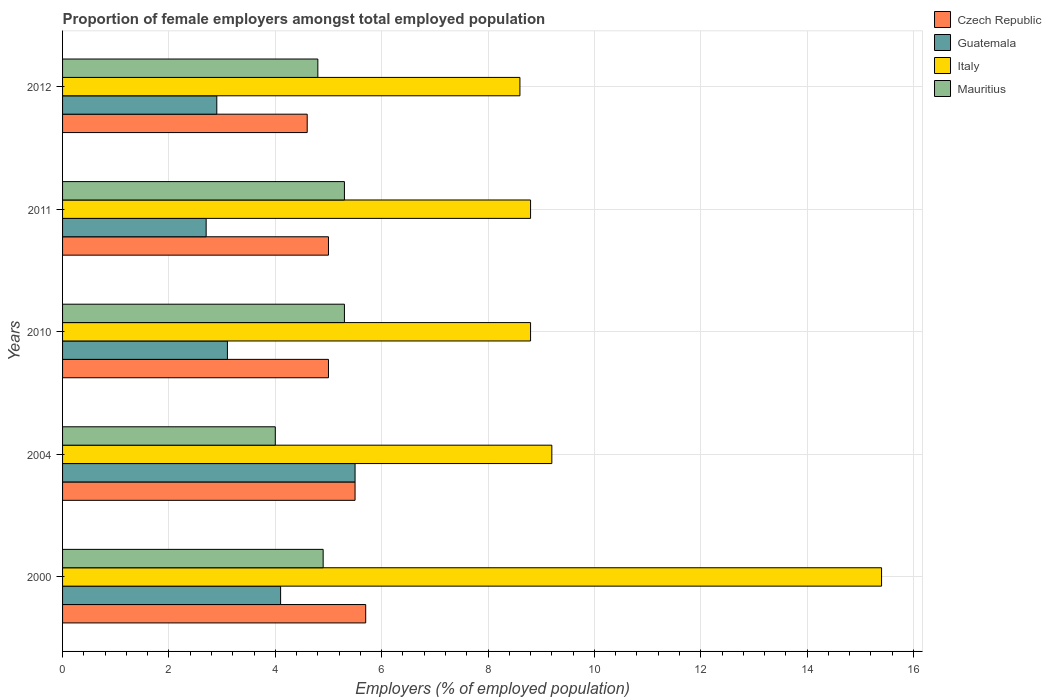How many different coloured bars are there?
Offer a terse response. 4. How many groups of bars are there?
Ensure brevity in your answer.  5. Are the number of bars per tick equal to the number of legend labels?
Your response must be concise. Yes. Are the number of bars on each tick of the Y-axis equal?
Provide a succinct answer. Yes. How many bars are there on the 1st tick from the top?
Your answer should be very brief. 4. What is the proportion of female employers in Mauritius in 2012?
Provide a short and direct response. 4.8. Across all years, what is the maximum proportion of female employers in Italy?
Your answer should be compact. 15.4. Across all years, what is the minimum proportion of female employers in Italy?
Your response must be concise. 8.6. In which year was the proportion of female employers in Italy maximum?
Give a very brief answer. 2000. What is the total proportion of female employers in Italy in the graph?
Provide a short and direct response. 50.8. What is the difference between the proportion of female employers in Czech Republic in 2010 and that in 2012?
Offer a terse response. 0.4. What is the difference between the proportion of female employers in Czech Republic in 2011 and the proportion of female employers in Mauritius in 2012?
Your answer should be compact. 0.2. What is the average proportion of female employers in Italy per year?
Your answer should be very brief. 10.16. In the year 2011, what is the difference between the proportion of female employers in Guatemala and proportion of female employers in Italy?
Offer a terse response. -6.1. In how many years, is the proportion of female employers in Guatemala greater than 7.6 %?
Provide a succinct answer. 0. What is the ratio of the proportion of female employers in Guatemala in 2004 to that in 2010?
Keep it short and to the point. 1.77. Is the proportion of female employers in Czech Republic in 2010 less than that in 2012?
Your answer should be very brief. No. Is the difference between the proportion of female employers in Guatemala in 2000 and 2010 greater than the difference between the proportion of female employers in Italy in 2000 and 2010?
Make the answer very short. No. What is the difference between the highest and the second highest proportion of female employers in Italy?
Keep it short and to the point. 6.2. What is the difference between the highest and the lowest proportion of female employers in Italy?
Provide a short and direct response. 6.8. In how many years, is the proportion of female employers in Mauritius greater than the average proportion of female employers in Mauritius taken over all years?
Keep it short and to the point. 3. What does the 4th bar from the top in 2012 represents?
Your answer should be compact. Czech Republic. What does the 4th bar from the bottom in 2012 represents?
Keep it short and to the point. Mauritius. How many bars are there?
Give a very brief answer. 20. Are the values on the major ticks of X-axis written in scientific E-notation?
Offer a very short reply. No. Where does the legend appear in the graph?
Your answer should be very brief. Top right. How many legend labels are there?
Offer a terse response. 4. How are the legend labels stacked?
Make the answer very short. Vertical. What is the title of the graph?
Your response must be concise. Proportion of female employers amongst total employed population. What is the label or title of the X-axis?
Your answer should be compact. Employers (% of employed population). What is the label or title of the Y-axis?
Your answer should be compact. Years. What is the Employers (% of employed population) in Czech Republic in 2000?
Make the answer very short. 5.7. What is the Employers (% of employed population) in Guatemala in 2000?
Offer a very short reply. 4.1. What is the Employers (% of employed population) in Italy in 2000?
Give a very brief answer. 15.4. What is the Employers (% of employed population) in Mauritius in 2000?
Ensure brevity in your answer.  4.9. What is the Employers (% of employed population) in Guatemala in 2004?
Your answer should be compact. 5.5. What is the Employers (% of employed population) in Italy in 2004?
Provide a short and direct response. 9.2. What is the Employers (% of employed population) of Czech Republic in 2010?
Make the answer very short. 5. What is the Employers (% of employed population) of Guatemala in 2010?
Your response must be concise. 3.1. What is the Employers (% of employed population) of Italy in 2010?
Provide a short and direct response. 8.8. What is the Employers (% of employed population) of Mauritius in 2010?
Offer a very short reply. 5.3. What is the Employers (% of employed population) in Czech Republic in 2011?
Make the answer very short. 5. What is the Employers (% of employed population) of Guatemala in 2011?
Your response must be concise. 2.7. What is the Employers (% of employed population) of Italy in 2011?
Offer a terse response. 8.8. What is the Employers (% of employed population) in Mauritius in 2011?
Your response must be concise. 5.3. What is the Employers (% of employed population) of Czech Republic in 2012?
Provide a succinct answer. 4.6. What is the Employers (% of employed population) in Guatemala in 2012?
Provide a short and direct response. 2.9. What is the Employers (% of employed population) in Italy in 2012?
Offer a terse response. 8.6. What is the Employers (% of employed population) of Mauritius in 2012?
Your response must be concise. 4.8. Across all years, what is the maximum Employers (% of employed population) of Czech Republic?
Your answer should be very brief. 5.7. Across all years, what is the maximum Employers (% of employed population) in Italy?
Your answer should be very brief. 15.4. Across all years, what is the maximum Employers (% of employed population) in Mauritius?
Make the answer very short. 5.3. Across all years, what is the minimum Employers (% of employed population) in Czech Republic?
Keep it short and to the point. 4.6. Across all years, what is the minimum Employers (% of employed population) in Guatemala?
Your answer should be very brief. 2.7. Across all years, what is the minimum Employers (% of employed population) of Italy?
Offer a very short reply. 8.6. Across all years, what is the minimum Employers (% of employed population) of Mauritius?
Ensure brevity in your answer.  4. What is the total Employers (% of employed population) in Czech Republic in the graph?
Offer a very short reply. 25.8. What is the total Employers (% of employed population) in Guatemala in the graph?
Give a very brief answer. 18.3. What is the total Employers (% of employed population) of Italy in the graph?
Your answer should be very brief. 50.8. What is the total Employers (% of employed population) in Mauritius in the graph?
Your response must be concise. 24.3. What is the difference between the Employers (% of employed population) of Italy in 2000 and that in 2010?
Make the answer very short. 6.6. What is the difference between the Employers (% of employed population) in Mauritius in 2000 and that in 2010?
Your answer should be compact. -0.4. What is the difference between the Employers (% of employed population) in Czech Republic in 2000 and that in 2011?
Ensure brevity in your answer.  0.7. What is the difference between the Employers (% of employed population) of Italy in 2000 and that in 2011?
Your answer should be very brief. 6.6. What is the difference between the Employers (% of employed population) in Mauritius in 2000 and that in 2011?
Make the answer very short. -0.4. What is the difference between the Employers (% of employed population) of Italy in 2004 and that in 2010?
Make the answer very short. 0.4. What is the difference between the Employers (% of employed population) in Guatemala in 2004 and that in 2011?
Provide a succinct answer. 2.8. What is the difference between the Employers (% of employed population) in Czech Republic in 2004 and that in 2012?
Give a very brief answer. 0.9. What is the difference between the Employers (% of employed population) of Italy in 2004 and that in 2012?
Provide a short and direct response. 0.6. What is the difference between the Employers (% of employed population) of Mauritius in 2004 and that in 2012?
Your answer should be compact. -0.8. What is the difference between the Employers (% of employed population) of Czech Republic in 2010 and that in 2011?
Your response must be concise. 0. What is the difference between the Employers (% of employed population) of Guatemala in 2010 and that in 2011?
Make the answer very short. 0.4. What is the difference between the Employers (% of employed population) of Mauritius in 2010 and that in 2011?
Ensure brevity in your answer.  0. What is the difference between the Employers (% of employed population) of Czech Republic in 2010 and that in 2012?
Offer a terse response. 0.4. What is the difference between the Employers (% of employed population) of Guatemala in 2010 and that in 2012?
Your answer should be very brief. 0.2. What is the difference between the Employers (% of employed population) of Guatemala in 2011 and that in 2012?
Your answer should be compact. -0.2. What is the difference between the Employers (% of employed population) of Italy in 2011 and that in 2012?
Make the answer very short. 0.2. What is the difference between the Employers (% of employed population) of Czech Republic in 2000 and the Employers (% of employed population) of Guatemala in 2004?
Make the answer very short. 0.2. What is the difference between the Employers (% of employed population) of Czech Republic in 2000 and the Employers (% of employed population) of Mauritius in 2004?
Your response must be concise. 1.7. What is the difference between the Employers (% of employed population) in Guatemala in 2000 and the Employers (% of employed population) in Italy in 2004?
Your response must be concise. -5.1. What is the difference between the Employers (% of employed population) of Guatemala in 2000 and the Employers (% of employed population) of Mauritius in 2004?
Your answer should be compact. 0.1. What is the difference between the Employers (% of employed population) of Czech Republic in 2000 and the Employers (% of employed population) of Guatemala in 2010?
Keep it short and to the point. 2.6. What is the difference between the Employers (% of employed population) in Guatemala in 2000 and the Employers (% of employed population) in Italy in 2010?
Your answer should be very brief. -4.7. What is the difference between the Employers (% of employed population) in Guatemala in 2000 and the Employers (% of employed population) in Mauritius in 2010?
Your answer should be very brief. -1.2. What is the difference between the Employers (% of employed population) of Czech Republic in 2000 and the Employers (% of employed population) of Guatemala in 2011?
Offer a very short reply. 3. What is the difference between the Employers (% of employed population) in Guatemala in 2000 and the Employers (% of employed population) in Mauritius in 2011?
Ensure brevity in your answer.  -1.2. What is the difference between the Employers (% of employed population) in Italy in 2000 and the Employers (% of employed population) in Mauritius in 2011?
Your answer should be compact. 10.1. What is the difference between the Employers (% of employed population) of Czech Republic in 2000 and the Employers (% of employed population) of Mauritius in 2012?
Provide a succinct answer. 0.9. What is the difference between the Employers (% of employed population) of Guatemala in 2000 and the Employers (% of employed population) of Italy in 2012?
Keep it short and to the point. -4.5. What is the difference between the Employers (% of employed population) in Czech Republic in 2004 and the Employers (% of employed population) in Italy in 2010?
Your response must be concise. -3.3. What is the difference between the Employers (% of employed population) in Czech Republic in 2004 and the Employers (% of employed population) in Mauritius in 2010?
Keep it short and to the point. 0.2. What is the difference between the Employers (% of employed population) in Guatemala in 2004 and the Employers (% of employed population) in Italy in 2010?
Offer a very short reply. -3.3. What is the difference between the Employers (% of employed population) of Czech Republic in 2004 and the Employers (% of employed population) of Italy in 2011?
Make the answer very short. -3.3. What is the difference between the Employers (% of employed population) of Czech Republic in 2004 and the Employers (% of employed population) of Mauritius in 2011?
Offer a very short reply. 0.2. What is the difference between the Employers (% of employed population) of Guatemala in 2004 and the Employers (% of employed population) of Italy in 2011?
Offer a terse response. -3.3. What is the difference between the Employers (% of employed population) in Czech Republic in 2004 and the Employers (% of employed population) in Guatemala in 2012?
Your answer should be compact. 2.6. What is the difference between the Employers (% of employed population) of Czech Republic in 2004 and the Employers (% of employed population) of Italy in 2012?
Provide a short and direct response. -3.1. What is the difference between the Employers (% of employed population) of Guatemala in 2004 and the Employers (% of employed population) of Italy in 2012?
Your answer should be compact. -3.1. What is the difference between the Employers (% of employed population) in Guatemala in 2004 and the Employers (% of employed population) in Mauritius in 2012?
Offer a terse response. 0.7. What is the difference between the Employers (% of employed population) of Czech Republic in 2010 and the Employers (% of employed population) of Mauritius in 2011?
Your response must be concise. -0.3. What is the difference between the Employers (% of employed population) of Guatemala in 2010 and the Employers (% of employed population) of Italy in 2011?
Ensure brevity in your answer.  -5.7. What is the difference between the Employers (% of employed population) of Czech Republic in 2011 and the Employers (% of employed population) of Italy in 2012?
Offer a terse response. -3.6. What is the difference between the Employers (% of employed population) in Czech Republic in 2011 and the Employers (% of employed population) in Mauritius in 2012?
Your answer should be very brief. 0.2. What is the difference between the Employers (% of employed population) in Guatemala in 2011 and the Employers (% of employed population) in Italy in 2012?
Provide a succinct answer. -5.9. What is the difference between the Employers (% of employed population) in Italy in 2011 and the Employers (% of employed population) in Mauritius in 2012?
Give a very brief answer. 4. What is the average Employers (% of employed population) of Czech Republic per year?
Your answer should be very brief. 5.16. What is the average Employers (% of employed population) of Guatemala per year?
Keep it short and to the point. 3.66. What is the average Employers (% of employed population) in Italy per year?
Give a very brief answer. 10.16. What is the average Employers (% of employed population) of Mauritius per year?
Provide a short and direct response. 4.86. In the year 2000, what is the difference between the Employers (% of employed population) of Czech Republic and Employers (% of employed population) of Guatemala?
Offer a very short reply. 1.6. In the year 2000, what is the difference between the Employers (% of employed population) of Czech Republic and Employers (% of employed population) of Italy?
Provide a succinct answer. -9.7. In the year 2000, what is the difference between the Employers (% of employed population) of Italy and Employers (% of employed population) of Mauritius?
Provide a succinct answer. 10.5. In the year 2004, what is the difference between the Employers (% of employed population) of Czech Republic and Employers (% of employed population) of Italy?
Offer a very short reply. -3.7. In the year 2004, what is the difference between the Employers (% of employed population) in Czech Republic and Employers (% of employed population) in Mauritius?
Provide a short and direct response. 1.5. In the year 2004, what is the difference between the Employers (% of employed population) in Guatemala and Employers (% of employed population) in Italy?
Your response must be concise. -3.7. In the year 2010, what is the difference between the Employers (% of employed population) of Guatemala and Employers (% of employed population) of Mauritius?
Give a very brief answer. -2.2. In the year 2011, what is the difference between the Employers (% of employed population) in Czech Republic and Employers (% of employed population) in Italy?
Keep it short and to the point. -3.8. In the year 2011, what is the difference between the Employers (% of employed population) in Czech Republic and Employers (% of employed population) in Mauritius?
Your answer should be compact. -0.3. In the year 2011, what is the difference between the Employers (% of employed population) in Guatemala and Employers (% of employed population) in Italy?
Provide a short and direct response. -6.1. In the year 2012, what is the difference between the Employers (% of employed population) in Czech Republic and Employers (% of employed population) in Italy?
Ensure brevity in your answer.  -4. In the year 2012, what is the difference between the Employers (% of employed population) of Czech Republic and Employers (% of employed population) of Mauritius?
Offer a terse response. -0.2. In the year 2012, what is the difference between the Employers (% of employed population) in Guatemala and Employers (% of employed population) in Mauritius?
Offer a terse response. -1.9. What is the ratio of the Employers (% of employed population) of Czech Republic in 2000 to that in 2004?
Your response must be concise. 1.04. What is the ratio of the Employers (% of employed population) in Guatemala in 2000 to that in 2004?
Offer a terse response. 0.75. What is the ratio of the Employers (% of employed population) of Italy in 2000 to that in 2004?
Keep it short and to the point. 1.67. What is the ratio of the Employers (% of employed population) of Mauritius in 2000 to that in 2004?
Make the answer very short. 1.23. What is the ratio of the Employers (% of employed population) of Czech Republic in 2000 to that in 2010?
Your response must be concise. 1.14. What is the ratio of the Employers (% of employed population) in Guatemala in 2000 to that in 2010?
Keep it short and to the point. 1.32. What is the ratio of the Employers (% of employed population) of Italy in 2000 to that in 2010?
Ensure brevity in your answer.  1.75. What is the ratio of the Employers (% of employed population) in Mauritius in 2000 to that in 2010?
Keep it short and to the point. 0.92. What is the ratio of the Employers (% of employed population) of Czech Republic in 2000 to that in 2011?
Provide a short and direct response. 1.14. What is the ratio of the Employers (% of employed population) of Guatemala in 2000 to that in 2011?
Offer a very short reply. 1.52. What is the ratio of the Employers (% of employed population) in Italy in 2000 to that in 2011?
Ensure brevity in your answer.  1.75. What is the ratio of the Employers (% of employed population) in Mauritius in 2000 to that in 2011?
Give a very brief answer. 0.92. What is the ratio of the Employers (% of employed population) in Czech Republic in 2000 to that in 2012?
Offer a terse response. 1.24. What is the ratio of the Employers (% of employed population) in Guatemala in 2000 to that in 2012?
Offer a terse response. 1.41. What is the ratio of the Employers (% of employed population) in Italy in 2000 to that in 2012?
Keep it short and to the point. 1.79. What is the ratio of the Employers (% of employed population) in Mauritius in 2000 to that in 2012?
Provide a succinct answer. 1.02. What is the ratio of the Employers (% of employed population) of Guatemala in 2004 to that in 2010?
Give a very brief answer. 1.77. What is the ratio of the Employers (% of employed population) of Italy in 2004 to that in 2010?
Offer a terse response. 1.05. What is the ratio of the Employers (% of employed population) in Mauritius in 2004 to that in 2010?
Your response must be concise. 0.75. What is the ratio of the Employers (% of employed population) in Guatemala in 2004 to that in 2011?
Give a very brief answer. 2.04. What is the ratio of the Employers (% of employed population) of Italy in 2004 to that in 2011?
Ensure brevity in your answer.  1.05. What is the ratio of the Employers (% of employed population) of Mauritius in 2004 to that in 2011?
Your answer should be compact. 0.75. What is the ratio of the Employers (% of employed population) of Czech Republic in 2004 to that in 2012?
Give a very brief answer. 1.2. What is the ratio of the Employers (% of employed population) of Guatemala in 2004 to that in 2012?
Offer a terse response. 1.9. What is the ratio of the Employers (% of employed population) of Italy in 2004 to that in 2012?
Offer a terse response. 1.07. What is the ratio of the Employers (% of employed population) of Mauritius in 2004 to that in 2012?
Offer a very short reply. 0.83. What is the ratio of the Employers (% of employed population) of Czech Republic in 2010 to that in 2011?
Provide a succinct answer. 1. What is the ratio of the Employers (% of employed population) of Guatemala in 2010 to that in 2011?
Provide a short and direct response. 1.15. What is the ratio of the Employers (% of employed population) in Mauritius in 2010 to that in 2011?
Your answer should be compact. 1. What is the ratio of the Employers (% of employed population) of Czech Republic in 2010 to that in 2012?
Your answer should be compact. 1.09. What is the ratio of the Employers (% of employed population) in Guatemala in 2010 to that in 2012?
Provide a succinct answer. 1.07. What is the ratio of the Employers (% of employed population) of Italy in 2010 to that in 2012?
Provide a short and direct response. 1.02. What is the ratio of the Employers (% of employed population) in Mauritius in 2010 to that in 2012?
Ensure brevity in your answer.  1.1. What is the ratio of the Employers (% of employed population) of Czech Republic in 2011 to that in 2012?
Keep it short and to the point. 1.09. What is the ratio of the Employers (% of employed population) in Italy in 2011 to that in 2012?
Your response must be concise. 1.02. What is the ratio of the Employers (% of employed population) in Mauritius in 2011 to that in 2012?
Ensure brevity in your answer.  1.1. What is the difference between the highest and the second highest Employers (% of employed population) of Guatemala?
Offer a terse response. 1.4. What is the difference between the highest and the second highest Employers (% of employed population) of Italy?
Your answer should be compact. 6.2. What is the difference between the highest and the lowest Employers (% of employed population) of Czech Republic?
Provide a short and direct response. 1.1. What is the difference between the highest and the lowest Employers (% of employed population) in Guatemala?
Keep it short and to the point. 2.8. What is the difference between the highest and the lowest Employers (% of employed population) in Italy?
Ensure brevity in your answer.  6.8. What is the difference between the highest and the lowest Employers (% of employed population) in Mauritius?
Keep it short and to the point. 1.3. 